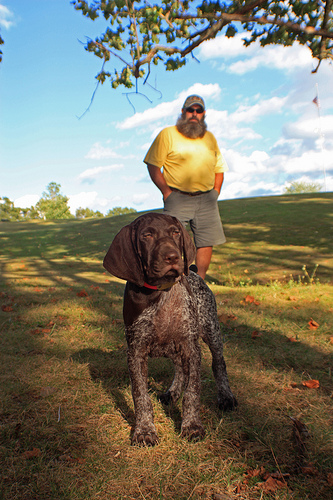Please provide a short description for this region: [0.45, 0.17, 0.64, 0.56]. In the specified region, a man is seen wearing reflective sunglasses, adding style to his casual outfit. 